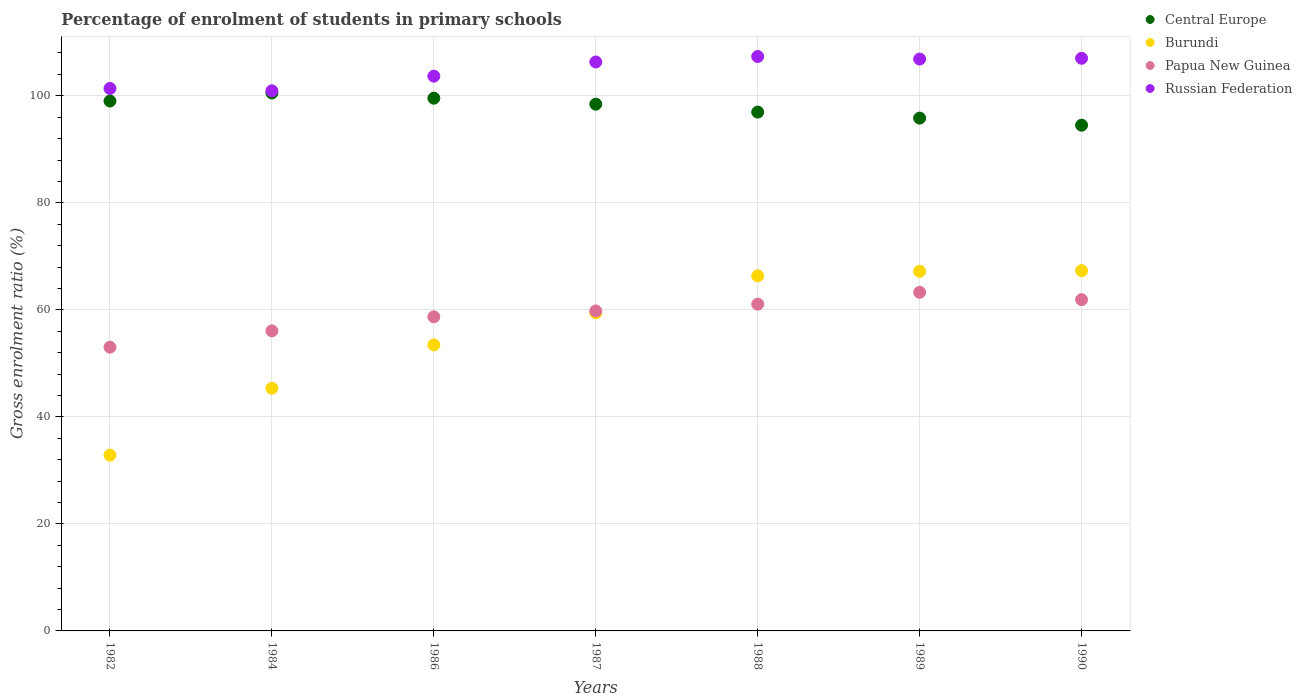How many different coloured dotlines are there?
Ensure brevity in your answer.  4. What is the percentage of students enrolled in primary schools in Central Europe in 1986?
Provide a succinct answer. 99.55. Across all years, what is the maximum percentage of students enrolled in primary schools in Russian Federation?
Give a very brief answer. 107.34. Across all years, what is the minimum percentage of students enrolled in primary schools in Papua New Guinea?
Your answer should be compact. 53.02. In which year was the percentage of students enrolled in primary schools in Russian Federation maximum?
Ensure brevity in your answer.  1988. What is the total percentage of students enrolled in primary schools in Papua New Guinea in the graph?
Provide a succinct answer. 413.85. What is the difference between the percentage of students enrolled in primary schools in Central Europe in 1984 and that in 1989?
Offer a very short reply. 4.69. What is the difference between the percentage of students enrolled in primary schools in Central Europe in 1988 and the percentage of students enrolled in primary schools in Burundi in 1989?
Offer a very short reply. 29.74. What is the average percentage of students enrolled in primary schools in Burundi per year?
Your answer should be very brief. 56. In the year 1988, what is the difference between the percentage of students enrolled in primary schools in Russian Federation and percentage of students enrolled in primary schools in Papua New Guinea?
Give a very brief answer. 46.28. What is the ratio of the percentage of students enrolled in primary schools in Russian Federation in 1988 to that in 1990?
Ensure brevity in your answer.  1. What is the difference between the highest and the second highest percentage of students enrolled in primary schools in Papua New Guinea?
Your response must be concise. 1.37. What is the difference between the highest and the lowest percentage of students enrolled in primary schools in Burundi?
Make the answer very short. 34.46. In how many years, is the percentage of students enrolled in primary schools in Burundi greater than the average percentage of students enrolled in primary schools in Burundi taken over all years?
Offer a very short reply. 4. Is the sum of the percentage of students enrolled in primary schools in Russian Federation in 1989 and 1990 greater than the maximum percentage of students enrolled in primary schools in Central Europe across all years?
Your response must be concise. Yes. Is it the case that in every year, the sum of the percentage of students enrolled in primary schools in Central Europe and percentage of students enrolled in primary schools in Russian Federation  is greater than the sum of percentage of students enrolled in primary schools in Papua New Guinea and percentage of students enrolled in primary schools in Burundi?
Your answer should be compact. Yes. Is the percentage of students enrolled in primary schools in Papua New Guinea strictly greater than the percentage of students enrolled in primary schools in Central Europe over the years?
Make the answer very short. No. How many years are there in the graph?
Provide a succinct answer. 7. What is the difference between two consecutive major ticks on the Y-axis?
Your answer should be compact. 20. Does the graph contain any zero values?
Provide a short and direct response. No. Does the graph contain grids?
Your answer should be very brief. Yes. What is the title of the graph?
Your response must be concise. Percentage of enrolment of students in primary schools. What is the label or title of the Y-axis?
Provide a succinct answer. Gross enrolment ratio (%). What is the Gross enrolment ratio (%) of Central Europe in 1982?
Your answer should be very brief. 99.02. What is the Gross enrolment ratio (%) in Burundi in 1982?
Offer a terse response. 32.86. What is the Gross enrolment ratio (%) of Papua New Guinea in 1982?
Your response must be concise. 53.02. What is the Gross enrolment ratio (%) in Russian Federation in 1982?
Offer a terse response. 101.37. What is the Gross enrolment ratio (%) in Central Europe in 1984?
Keep it short and to the point. 100.52. What is the Gross enrolment ratio (%) of Burundi in 1984?
Provide a short and direct response. 45.35. What is the Gross enrolment ratio (%) of Papua New Guinea in 1984?
Make the answer very short. 56.07. What is the Gross enrolment ratio (%) of Russian Federation in 1984?
Keep it short and to the point. 100.93. What is the Gross enrolment ratio (%) in Central Europe in 1986?
Your answer should be very brief. 99.55. What is the Gross enrolment ratio (%) in Burundi in 1986?
Keep it short and to the point. 53.45. What is the Gross enrolment ratio (%) in Papua New Guinea in 1986?
Give a very brief answer. 58.7. What is the Gross enrolment ratio (%) in Russian Federation in 1986?
Your answer should be very brief. 103.67. What is the Gross enrolment ratio (%) in Central Europe in 1987?
Your response must be concise. 98.44. What is the Gross enrolment ratio (%) in Burundi in 1987?
Your answer should be very brief. 59.44. What is the Gross enrolment ratio (%) in Papua New Guinea in 1987?
Your response must be concise. 59.8. What is the Gross enrolment ratio (%) in Russian Federation in 1987?
Provide a succinct answer. 106.32. What is the Gross enrolment ratio (%) in Central Europe in 1988?
Make the answer very short. 96.96. What is the Gross enrolment ratio (%) of Burundi in 1988?
Your response must be concise. 66.36. What is the Gross enrolment ratio (%) in Papua New Guinea in 1988?
Provide a succinct answer. 61.07. What is the Gross enrolment ratio (%) of Russian Federation in 1988?
Ensure brevity in your answer.  107.34. What is the Gross enrolment ratio (%) of Central Europe in 1989?
Your response must be concise. 95.83. What is the Gross enrolment ratio (%) of Burundi in 1989?
Ensure brevity in your answer.  67.22. What is the Gross enrolment ratio (%) of Papua New Guinea in 1989?
Ensure brevity in your answer.  63.28. What is the Gross enrolment ratio (%) of Russian Federation in 1989?
Make the answer very short. 106.87. What is the Gross enrolment ratio (%) in Central Europe in 1990?
Your response must be concise. 94.51. What is the Gross enrolment ratio (%) of Burundi in 1990?
Provide a succinct answer. 67.32. What is the Gross enrolment ratio (%) of Papua New Guinea in 1990?
Give a very brief answer. 61.91. What is the Gross enrolment ratio (%) in Russian Federation in 1990?
Keep it short and to the point. 107.01. Across all years, what is the maximum Gross enrolment ratio (%) of Central Europe?
Your answer should be very brief. 100.52. Across all years, what is the maximum Gross enrolment ratio (%) of Burundi?
Your answer should be very brief. 67.32. Across all years, what is the maximum Gross enrolment ratio (%) in Papua New Guinea?
Provide a succinct answer. 63.28. Across all years, what is the maximum Gross enrolment ratio (%) in Russian Federation?
Provide a succinct answer. 107.34. Across all years, what is the minimum Gross enrolment ratio (%) in Central Europe?
Offer a very short reply. 94.51. Across all years, what is the minimum Gross enrolment ratio (%) in Burundi?
Provide a succinct answer. 32.86. Across all years, what is the minimum Gross enrolment ratio (%) in Papua New Guinea?
Offer a terse response. 53.02. Across all years, what is the minimum Gross enrolment ratio (%) of Russian Federation?
Your response must be concise. 100.93. What is the total Gross enrolment ratio (%) of Central Europe in the graph?
Give a very brief answer. 684.83. What is the total Gross enrolment ratio (%) in Burundi in the graph?
Ensure brevity in your answer.  391.99. What is the total Gross enrolment ratio (%) in Papua New Guinea in the graph?
Make the answer very short. 413.85. What is the total Gross enrolment ratio (%) in Russian Federation in the graph?
Offer a terse response. 733.53. What is the difference between the Gross enrolment ratio (%) of Central Europe in 1982 and that in 1984?
Offer a very short reply. -1.5. What is the difference between the Gross enrolment ratio (%) in Burundi in 1982 and that in 1984?
Provide a succinct answer. -12.49. What is the difference between the Gross enrolment ratio (%) in Papua New Guinea in 1982 and that in 1984?
Provide a short and direct response. -3.05. What is the difference between the Gross enrolment ratio (%) in Russian Federation in 1982 and that in 1984?
Your answer should be compact. 0.44. What is the difference between the Gross enrolment ratio (%) in Central Europe in 1982 and that in 1986?
Provide a succinct answer. -0.53. What is the difference between the Gross enrolment ratio (%) in Burundi in 1982 and that in 1986?
Your response must be concise. -20.59. What is the difference between the Gross enrolment ratio (%) in Papua New Guinea in 1982 and that in 1986?
Provide a short and direct response. -5.68. What is the difference between the Gross enrolment ratio (%) in Russian Federation in 1982 and that in 1986?
Offer a very short reply. -2.3. What is the difference between the Gross enrolment ratio (%) in Central Europe in 1982 and that in 1987?
Your answer should be compact. 0.59. What is the difference between the Gross enrolment ratio (%) of Burundi in 1982 and that in 1987?
Give a very brief answer. -26.59. What is the difference between the Gross enrolment ratio (%) in Papua New Guinea in 1982 and that in 1987?
Offer a very short reply. -6.78. What is the difference between the Gross enrolment ratio (%) of Russian Federation in 1982 and that in 1987?
Your answer should be compact. -4.95. What is the difference between the Gross enrolment ratio (%) in Central Europe in 1982 and that in 1988?
Make the answer very short. 2.07. What is the difference between the Gross enrolment ratio (%) in Burundi in 1982 and that in 1988?
Your answer should be compact. -33.51. What is the difference between the Gross enrolment ratio (%) of Papua New Guinea in 1982 and that in 1988?
Keep it short and to the point. -8.05. What is the difference between the Gross enrolment ratio (%) of Russian Federation in 1982 and that in 1988?
Your answer should be very brief. -5.97. What is the difference between the Gross enrolment ratio (%) of Central Europe in 1982 and that in 1989?
Give a very brief answer. 3.19. What is the difference between the Gross enrolment ratio (%) in Burundi in 1982 and that in 1989?
Offer a terse response. -34.36. What is the difference between the Gross enrolment ratio (%) in Papua New Guinea in 1982 and that in 1989?
Ensure brevity in your answer.  -10.26. What is the difference between the Gross enrolment ratio (%) of Russian Federation in 1982 and that in 1989?
Your response must be concise. -5.49. What is the difference between the Gross enrolment ratio (%) of Central Europe in 1982 and that in 1990?
Offer a terse response. 4.51. What is the difference between the Gross enrolment ratio (%) in Burundi in 1982 and that in 1990?
Your answer should be compact. -34.46. What is the difference between the Gross enrolment ratio (%) in Papua New Guinea in 1982 and that in 1990?
Provide a succinct answer. -8.89. What is the difference between the Gross enrolment ratio (%) of Russian Federation in 1982 and that in 1990?
Make the answer very short. -5.64. What is the difference between the Gross enrolment ratio (%) of Central Europe in 1984 and that in 1986?
Offer a terse response. 0.97. What is the difference between the Gross enrolment ratio (%) of Burundi in 1984 and that in 1986?
Your answer should be very brief. -8.1. What is the difference between the Gross enrolment ratio (%) of Papua New Guinea in 1984 and that in 1986?
Make the answer very short. -2.63. What is the difference between the Gross enrolment ratio (%) of Russian Federation in 1984 and that in 1986?
Offer a very short reply. -2.74. What is the difference between the Gross enrolment ratio (%) of Central Europe in 1984 and that in 1987?
Give a very brief answer. 2.09. What is the difference between the Gross enrolment ratio (%) in Burundi in 1984 and that in 1987?
Your response must be concise. -14.09. What is the difference between the Gross enrolment ratio (%) in Papua New Guinea in 1984 and that in 1987?
Provide a succinct answer. -3.73. What is the difference between the Gross enrolment ratio (%) in Russian Federation in 1984 and that in 1987?
Your response must be concise. -5.39. What is the difference between the Gross enrolment ratio (%) in Central Europe in 1984 and that in 1988?
Your response must be concise. 3.56. What is the difference between the Gross enrolment ratio (%) of Burundi in 1984 and that in 1988?
Make the answer very short. -21.01. What is the difference between the Gross enrolment ratio (%) in Papua New Guinea in 1984 and that in 1988?
Keep it short and to the point. -5. What is the difference between the Gross enrolment ratio (%) in Russian Federation in 1984 and that in 1988?
Provide a short and direct response. -6.41. What is the difference between the Gross enrolment ratio (%) of Central Europe in 1984 and that in 1989?
Keep it short and to the point. 4.69. What is the difference between the Gross enrolment ratio (%) of Burundi in 1984 and that in 1989?
Your response must be concise. -21.87. What is the difference between the Gross enrolment ratio (%) of Papua New Guinea in 1984 and that in 1989?
Provide a succinct answer. -7.2. What is the difference between the Gross enrolment ratio (%) of Russian Federation in 1984 and that in 1989?
Offer a very short reply. -5.93. What is the difference between the Gross enrolment ratio (%) in Central Europe in 1984 and that in 1990?
Keep it short and to the point. 6.01. What is the difference between the Gross enrolment ratio (%) in Burundi in 1984 and that in 1990?
Offer a terse response. -21.97. What is the difference between the Gross enrolment ratio (%) in Papua New Guinea in 1984 and that in 1990?
Provide a short and direct response. -5.83. What is the difference between the Gross enrolment ratio (%) of Russian Federation in 1984 and that in 1990?
Make the answer very short. -6.08. What is the difference between the Gross enrolment ratio (%) in Central Europe in 1986 and that in 1987?
Provide a short and direct response. 1.12. What is the difference between the Gross enrolment ratio (%) in Burundi in 1986 and that in 1987?
Provide a succinct answer. -5.99. What is the difference between the Gross enrolment ratio (%) in Papua New Guinea in 1986 and that in 1987?
Make the answer very short. -1.11. What is the difference between the Gross enrolment ratio (%) in Russian Federation in 1986 and that in 1987?
Ensure brevity in your answer.  -2.65. What is the difference between the Gross enrolment ratio (%) of Central Europe in 1986 and that in 1988?
Your answer should be very brief. 2.6. What is the difference between the Gross enrolment ratio (%) of Burundi in 1986 and that in 1988?
Offer a very short reply. -12.92. What is the difference between the Gross enrolment ratio (%) of Papua New Guinea in 1986 and that in 1988?
Your answer should be compact. -2.37. What is the difference between the Gross enrolment ratio (%) in Russian Federation in 1986 and that in 1988?
Give a very brief answer. -3.67. What is the difference between the Gross enrolment ratio (%) in Central Europe in 1986 and that in 1989?
Your answer should be compact. 3.72. What is the difference between the Gross enrolment ratio (%) in Burundi in 1986 and that in 1989?
Your answer should be very brief. -13.77. What is the difference between the Gross enrolment ratio (%) of Papua New Guinea in 1986 and that in 1989?
Provide a short and direct response. -4.58. What is the difference between the Gross enrolment ratio (%) in Russian Federation in 1986 and that in 1989?
Provide a short and direct response. -3.2. What is the difference between the Gross enrolment ratio (%) in Central Europe in 1986 and that in 1990?
Your response must be concise. 5.04. What is the difference between the Gross enrolment ratio (%) in Burundi in 1986 and that in 1990?
Offer a very short reply. -13.87. What is the difference between the Gross enrolment ratio (%) in Papua New Guinea in 1986 and that in 1990?
Give a very brief answer. -3.21. What is the difference between the Gross enrolment ratio (%) in Russian Federation in 1986 and that in 1990?
Ensure brevity in your answer.  -3.34. What is the difference between the Gross enrolment ratio (%) of Central Europe in 1987 and that in 1988?
Your answer should be very brief. 1.48. What is the difference between the Gross enrolment ratio (%) in Burundi in 1987 and that in 1988?
Provide a succinct answer. -6.92. What is the difference between the Gross enrolment ratio (%) in Papua New Guinea in 1987 and that in 1988?
Offer a terse response. -1.27. What is the difference between the Gross enrolment ratio (%) in Russian Federation in 1987 and that in 1988?
Offer a terse response. -1.02. What is the difference between the Gross enrolment ratio (%) in Central Europe in 1987 and that in 1989?
Ensure brevity in your answer.  2.6. What is the difference between the Gross enrolment ratio (%) of Burundi in 1987 and that in 1989?
Offer a terse response. -7.78. What is the difference between the Gross enrolment ratio (%) in Papua New Guinea in 1987 and that in 1989?
Offer a terse response. -3.47. What is the difference between the Gross enrolment ratio (%) of Russian Federation in 1987 and that in 1989?
Keep it short and to the point. -0.54. What is the difference between the Gross enrolment ratio (%) of Central Europe in 1987 and that in 1990?
Offer a very short reply. 3.93. What is the difference between the Gross enrolment ratio (%) of Burundi in 1987 and that in 1990?
Give a very brief answer. -7.88. What is the difference between the Gross enrolment ratio (%) of Papua New Guinea in 1987 and that in 1990?
Offer a very short reply. -2.1. What is the difference between the Gross enrolment ratio (%) of Russian Federation in 1987 and that in 1990?
Your answer should be very brief. -0.69. What is the difference between the Gross enrolment ratio (%) of Central Europe in 1988 and that in 1989?
Give a very brief answer. 1.12. What is the difference between the Gross enrolment ratio (%) in Burundi in 1988 and that in 1989?
Your answer should be compact. -0.85. What is the difference between the Gross enrolment ratio (%) in Papua New Guinea in 1988 and that in 1989?
Ensure brevity in your answer.  -2.21. What is the difference between the Gross enrolment ratio (%) in Russian Federation in 1988 and that in 1989?
Provide a short and direct response. 0.48. What is the difference between the Gross enrolment ratio (%) of Central Europe in 1988 and that in 1990?
Give a very brief answer. 2.45. What is the difference between the Gross enrolment ratio (%) of Burundi in 1988 and that in 1990?
Your answer should be very brief. -0.96. What is the difference between the Gross enrolment ratio (%) of Papua New Guinea in 1988 and that in 1990?
Make the answer very short. -0.84. What is the difference between the Gross enrolment ratio (%) of Russian Federation in 1988 and that in 1990?
Offer a very short reply. 0.33. What is the difference between the Gross enrolment ratio (%) of Central Europe in 1989 and that in 1990?
Make the answer very short. 1.32. What is the difference between the Gross enrolment ratio (%) of Burundi in 1989 and that in 1990?
Provide a succinct answer. -0.1. What is the difference between the Gross enrolment ratio (%) in Papua New Guinea in 1989 and that in 1990?
Offer a very short reply. 1.37. What is the difference between the Gross enrolment ratio (%) in Russian Federation in 1989 and that in 1990?
Provide a short and direct response. -0.15. What is the difference between the Gross enrolment ratio (%) of Central Europe in 1982 and the Gross enrolment ratio (%) of Burundi in 1984?
Give a very brief answer. 53.67. What is the difference between the Gross enrolment ratio (%) of Central Europe in 1982 and the Gross enrolment ratio (%) of Papua New Guinea in 1984?
Offer a terse response. 42.95. What is the difference between the Gross enrolment ratio (%) in Central Europe in 1982 and the Gross enrolment ratio (%) in Russian Federation in 1984?
Make the answer very short. -1.91. What is the difference between the Gross enrolment ratio (%) of Burundi in 1982 and the Gross enrolment ratio (%) of Papua New Guinea in 1984?
Your response must be concise. -23.22. What is the difference between the Gross enrolment ratio (%) of Burundi in 1982 and the Gross enrolment ratio (%) of Russian Federation in 1984?
Provide a short and direct response. -68.08. What is the difference between the Gross enrolment ratio (%) in Papua New Guinea in 1982 and the Gross enrolment ratio (%) in Russian Federation in 1984?
Ensure brevity in your answer.  -47.91. What is the difference between the Gross enrolment ratio (%) in Central Europe in 1982 and the Gross enrolment ratio (%) in Burundi in 1986?
Offer a terse response. 45.58. What is the difference between the Gross enrolment ratio (%) in Central Europe in 1982 and the Gross enrolment ratio (%) in Papua New Guinea in 1986?
Your response must be concise. 40.33. What is the difference between the Gross enrolment ratio (%) of Central Europe in 1982 and the Gross enrolment ratio (%) of Russian Federation in 1986?
Provide a short and direct response. -4.65. What is the difference between the Gross enrolment ratio (%) of Burundi in 1982 and the Gross enrolment ratio (%) of Papua New Guinea in 1986?
Provide a short and direct response. -25.84. What is the difference between the Gross enrolment ratio (%) of Burundi in 1982 and the Gross enrolment ratio (%) of Russian Federation in 1986?
Your answer should be compact. -70.81. What is the difference between the Gross enrolment ratio (%) in Papua New Guinea in 1982 and the Gross enrolment ratio (%) in Russian Federation in 1986?
Ensure brevity in your answer.  -50.65. What is the difference between the Gross enrolment ratio (%) in Central Europe in 1982 and the Gross enrolment ratio (%) in Burundi in 1987?
Your response must be concise. 39.58. What is the difference between the Gross enrolment ratio (%) of Central Europe in 1982 and the Gross enrolment ratio (%) of Papua New Guinea in 1987?
Your response must be concise. 39.22. What is the difference between the Gross enrolment ratio (%) in Central Europe in 1982 and the Gross enrolment ratio (%) in Russian Federation in 1987?
Offer a very short reply. -7.3. What is the difference between the Gross enrolment ratio (%) in Burundi in 1982 and the Gross enrolment ratio (%) in Papua New Guinea in 1987?
Offer a terse response. -26.95. What is the difference between the Gross enrolment ratio (%) of Burundi in 1982 and the Gross enrolment ratio (%) of Russian Federation in 1987?
Your response must be concise. -73.47. What is the difference between the Gross enrolment ratio (%) of Papua New Guinea in 1982 and the Gross enrolment ratio (%) of Russian Federation in 1987?
Provide a succinct answer. -53.3. What is the difference between the Gross enrolment ratio (%) in Central Europe in 1982 and the Gross enrolment ratio (%) in Burundi in 1988?
Your answer should be very brief. 32.66. What is the difference between the Gross enrolment ratio (%) in Central Europe in 1982 and the Gross enrolment ratio (%) in Papua New Guinea in 1988?
Give a very brief answer. 37.95. What is the difference between the Gross enrolment ratio (%) of Central Europe in 1982 and the Gross enrolment ratio (%) of Russian Federation in 1988?
Make the answer very short. -8.32. What is the difference between the Gross enrolment ratio (%) in Burundi in 1982 and the Gross enrolment ratio (%) in Papua New Guinea in 1988?
Your answer should be very brief. -28.21. What is the difference between the Gross enrolment ratio (%) of Burundi in 1982 and the Gross enrolment ratio (%) of Russian Federation in 1988?
Ensure brevity in your answer.  -74.49. What is the difference between the Gross enrolment ratio (%) of Papua New Guinea in 1982 and the Gross enrolment ratio (%) of Russian Federation in 1988?
Offer a terse response. -54.32. What is the difference between the Gross enrolment ratio (%) in Central Europe in 1982 and the Gross enrolment ratio (%) in Burundi in 1989?
Provide a succinct answer. 31.81. What is the difference between the Gross enrolment ratio (%) of Central Europe in 1982 and the Gross enrolment ratio (%) of Papua New Guinea in 1989?
Keep it short and to the point. 35.75. What is the difference between the Gross enrolment ratio (%) in Central Europe in 1982 and the Gross enrolment ratio (%) in Russian Federation in 1989?
Keep it short and to the point. -7.84. What is the difference between the Gross enrolment ratio (%) in Burundi in 1982 and the Gross enrolment ratio (%) in Papua New Guinea in 1989?
Offer a terse response. -30.42. What is the difference between the Gross enrolment ratio (%) of Burundi in 1982 and the Gross enrolment ratio (%) of Russian Federation in 1989?
Provide a succinct answer. -74.01. What is the difference between the Gross enrolment ratio (%) of Papua New Guinea in 1982 and the Gross enrolment ratio (%) of Russian Federation in 1989?
Make the answer very short. -53.84. What is the difference between the Gross enrolment ratio (%) in Central Europe in 1982 and the Gross enrolment ratio (%) in Burundi in 1990?
Offer a terse response. 31.7. What is the difference between the Gross enrolment ratio (%) in Central Europe in 1982 and the Gross enrolment ratio (%) in Papua New Guinea in 1990?
Offer a terse response. 37.12. What is the difference between the Gross enrolment ratio (%) of Central Europe in 1982 and the Gross enrolment ratio (%) of Russian Federation in 1990?
Make the answer very short. -7.99. What is the difference between the Gross enrolment ratio (%) of Burundi in 1982 and the Gross enrolment ratio (%) of Papua New Guinea in 1990?
Offer a very short reply. -29.05. What is the difference between the Gross enrolment ratio (%) of Burundi in 1982 and the Gross enrolment ratio (%) of Russian Federation in 1990?
Give a very brief answer. -74.16. What is the difference between the Gross enrolment ratio (%) in Papua New Guinea in 1982 and the Gross enrolment ratio (%) in Russian Federation in 1990?
Provide a succinct answer. -53.99. What is the difference between the Gross enrolment ratio (%) in Central Europe in 1984 and the Gross enrolment ratio (%) in Burundi in 1986?
Make the answer very short. 47.08. What is the difference between the Gross enrolment ratio (%) in Central Europe in 1984 and the Gross enrolment ratio (%) in Papua New Guinea in 1986?
Make the answer very short. 41.82. What is the difference between the Gross enrolment ratio (%) in Central Europe in 1984 and the Gross enrolment ratio (%) in Russian Federation in 1986?
Provide a succinct answer. -3.15. What is the difference between the Gross enrolment ratio (%) of Burundi in 1984 and the Gross enrolment ratio (%) of Papua New Guinea in 1986?
Your answer should be compact. -13.35. What is the difference between the Gross enrolment ratio (%) in Burundi in 1984 and the Gross enrolment ratio (%) in Russian Federation in 1986?
Offer a very short reply. -58.32. What is the difference between the Gross enrolment ratio (%) in Papua New Guinea in 1984 and the Gross enrolment ratio (%) in Russian Federation in 1986?
Your answer should be very brief. -47.6. What is the difference between the Gross enrolment ratio (%) of Central Europe in 1984 and the Gross enrolment ratio (%) of Burundi in 1987?
Make the answer very short. 41.08. What is the difference between the Gross enrolment ratio (%) in Central Europe in 1984 and the Gross enrolment ratio (%) in Papua New Guinea in 1987?
Provide a succinct answer. 40.72. What is the difference between the Gross enrolment ratio (%) in Central Europe in 1984 and the Gross enrolment ratio (%) in Russian Federation in 1987?
Your answer should be compact. -5.8. What is the difference between the Gross enrolment ratio (%) in Burundi in 1984 and the Gross enrolment ratio (%) in Papua New Guinea in 1987?
Offer a terse response. -14.45. What is the difference between the Gross enrolment ratio (%) of Burundi in 1984 and the Gross enrolment ratio (%) of Russian Federation in 1987?
Your answer should be very brief. -60.98. What is the difference between the Gross enrolment ratio (%) in Papua New Guinea in 1984 and the Gross enrolment ratio (%) in Russian Federation in 1987?
Give a very brief answer. -50.25. What is the difference between the Gross enrolment ratio (%) of Central Europe in 1984 and the Gross enrolment ratio (%) of Burundi in 1988?
Ensure brevity in your answer.  34.16. What is the difference between the Gross enrolment ratio (%) in Central Europe in 1984 and the Gross enrolment ratio (%) in Papua New Guinea in 1988?
Your answer should be compact. 39.45. What is the difference between the Gross enrolment ratio (%) of Central Europe in 1984 and the Gross enrolment ratio (%) of Russian Federation in 1988?
Offer a terse response. -6.82. What is the difference between the Gross enrolment ratio (%) of Burundi in 1984 and the Gross enrolment ratio (%) of Papua New Guinea in 1988?
Your answer should be compact. -15.72. What is the difference between the Gross enrolment ratio (%) of Burundi in 1984 and the Gross enrolment ratio (%) of Russian Federation in 1988?
Make the answer very short. -62. What is the difference between the Gross enrolment ratio (%) in Papua New Guinea in 1984 and the Gross enrolment ratio (%) in Russian Federation in 1988?
Offer a terse response. -51.27. What is the difference between the Gross enrolment ratio (%) in Central Europe in 1984 and the Gross enrolment ratio (%) in Burundi in 1989?
Give a very brief answer. 33.31. What is the difference between the Gross enrolment ratio (%) of Central Europe in 1984 and the Gross enrolment ratio (%) of Papua New Guinea in 1989?
Ensure brevity in your answer.  37.24. What is the difference between the Gross enrolment ratio (%) of Central Europe in 1984 and the Gross enrolment ratio (%) of Russian Federation in 1989?
Make the answer very short. -6.34. What is the difference between the Gross enrolment ratio (%) in Burundi in 1984 and the Gross enrolment ratio (%) in Papua New Guinea in 1989?
Provide a succinct answer. -17.93. What is the difference between the Gross enrolment ratio (%) of Burundi in 1984 and the Gross enrolment ratio (%) of Russian Federation in 1989?
Provide a succinct answer. -61.52. What is the difference between the Gross enrolment ratio (%) of Papua New Guinea in 1984 and the Gross enrolment ratio (%) of Russian Federation in 1989?
Offer a very short reply. -50.79. What is the difference between the Gross enrolment ratio (%) of Central Europe in 1984 and the Gross enrolment ratio (%) of Burundi in 1990?
Your response must be concise. 33.2. What is the difference between the Gross enrolment ratio (%) of Central Europe in 1984 and the Gross enrolment ratio (%) of Papua New Guinea in 1990?
Offer a terse response. 38.62. What is the difference between the Gross enrolment ratio (%) of Central Europe in 1984 and the Gross enrolment ratio (%) of Russian Federation in 1990?
Keep it short and to the point. -6.49. What is the difference between the Gross enrolment ratio (%) in Burundi in 1984 and the Gross enrolment ratio (%) in Papua New Guinea in 1990?
Your response must be concise. -16.56. What is the difference between the Gross enrolment ratio (%) of Burundi in 1984 and the Gross enrolment ratio (%) of Russian Federation in 1990?
Keep it short and to the point. -61.66. What is the difference between the Gross enrolment ratio (%) in Papua New Guinea in 1984 and the Gross enrolment ratio (%) in Russian Federation in 1990?
Your response must be concise. -50.94. What is the difference between the Gross enrolment ratio (%) of Central Europe in 1986 and the Gross enrolment ratio (%) of Burundi in 1987?
Your answer should be compact. 40.11. What is the difference between the Gross enrolment ratio (%) in Central Europe in 1986 and the Gross enrolment ratio (%) in Papua New Guinea in 1987?
Offer a very short reply. 39.75. What is the difference between the Gross enrolment ratio (%) in Central Europe in 1986 and the Gross enrolment ratio (%) in Russian Federation in 1987?
Your answer should be compact. -6.77. What is the difference between the Gross enrolment ratio (%) of Burundi in 1986 and the Gross enrolment ratio (%) of Papua New Guinea in 1987?
Offer a very short reply. -6.36. What is the difference between the Gross enrolment ratio (%) of Burundi in 1986 and the Gross enrolment ratio (%) of Russian Federation in 1987?
Ensure brevity in your answer.  -52.88. What is the difference between the Gross enrolment ratio (%) in Papua New Guinea in 1986 and the Gross enrolment ratio (%) in Russian Federation in 1987?
Ensure brevity in your answer.  -47.63. What is the difference between the Gross enrolment ratio (%) of Central Europe in 1986 and the Gross enrolment ratio (%) of Burundi in 1988?
Offer a terse response. 33.19. What is the difference between the Gross enrolment ratio (%) in Central Europe in 1986 and the Gross enrolment ratio (%) in Papua New Guinea in 1988?
Your answer should be very brief. 38.48. What is the difference between the Gross enrolment ratio (%) in Central Europe in 1986 and the Gross enrolment ratio (%) in Russian Federation in 1988?
Provide a short and direct response. -7.79. What is the difference between the Gross enrolment ratio (%) in Burundi in 1986 and the Gross enrolment ratio (%) in Papua New Guinea in 1988?
Provide a succinct answer. -7.62. What is the difference between the Gross enrolment ratio (%) of Burundi in 1986 and the Gross enrolment ratio (%) of Russian Federation in 1988?
Give a very brief answer. -53.9. What is the difference between the Gross enrolment ratio (%) in Papua New Guinea in 1986 and the Gross enrolment ratio (%) in Russian Federation in 1988?
Offer a terse response. -48.65. What is the difference between the Gross enrolment ratio (%) of Central Europe in 1986 and the Gross enrolment ratio (%) of Burundi in 1989?
Make the answer very short. 32.34. What is the difference between the Gross enrolment ratio (%) of Central Europe in 1986 and the Gross enrolment ratio (%) of Papua New Guinea in 1989?
Provide a succinct answer. 36.28. What is the difference between the Gross enrolment ratio (%) in Central Europe in 1986 and the Gross enrolment ratio (%) in Russian Federation in 1989?
Offer a terse response. -7.31. What is the difference between the Gross enrolment ratio (%) of Burundi in 1986 and the Gross enrolment ratio (%) of Papua New Guinea in 1989?
Your answer should be very brief. -9.83. What is the difference between the Gross enrolment ratio (%) of Burundi in 1986 and the Gross enrolment ratio (%) of Russian Federation in 1989?
Offer a very short reply. -53.42. What is the difference between the Gross enrolment ratio (%) in Papua New Guinea in 1986 and the Gross enrolment ratio (%) in Russian Federation in 1989?
Your answer should be very brief. -48.17. What is the difference between the Gross enrolment ratio (%) in Central Europe in 1986 and the Gross enrolment ratio (%) in Burundi in 1990?
Give a very brief answer. 32.23. What is the difference between the Gross enrolment ratio (%) of Central Europe in 1986 and the Gross enrolment ratio (%) of Papua New Guinea in 1990?
Offer a very short reply. 37.65. What is the difference between the Gross enrolment ratio (%) in Central Europe in 1986 and the Gross enrolment ratio (%) in Russian Federation in 1990?
Offer a terse response. -7.46. What is the difference between the Gross enrolment ratio (%) of Burundi in 1986 and the Gross enrolment ratio (%) of Papua New Guinea in 1990?
Your response must be concise. -8.46. What is the difference between the Gross enrolment ratio (%) in Burundi in 1986 and the Gross enrolment ratio (%) in Russian Federation in 1990?
Offer a very short reply. -53.57. What is the difference between the Gross enrolment ratio (%) in Papua New Guinea in 1986 and the Gross enrolment ratio (%) in Russian Federation in 1990?
Your answer should be very brief. -48.32. What is the difference between the Gross enrolment ratio (%) in Central Europe in 1987 and the Gross enrolment ratio (%) in Burundi in 1988?
Provide a succinct answer. 32.07. What is the difference between the Gross enrolment ratio (%) of Central Europe in 1987 and the Gross enrolment ratio (%) of Papua New Guinea in 1988?
Offer a very short reply. 37.37. What is the difference between the Gross enrolment ratio (%) of Central Europe in 1987 and the Gross enrolment ratio (%) of Russian Federation in 1988?
Provide a short and direct response. -8.91. What is the difference between the Gross enrolment ratio (%) of Burundi in 1987 and the Gross enrolment ratio (%) of Papua New Guinea in 1988?
Give a very brief answer. -1.63. What is the difference between the Gross enrolment ratio (%) of Burundi in 1987 and the Gross enrolment ratio (%) of Russian Federation in 1988?
Offer a terse response. -47.9. What is the difference between the Gross enrolment ratio (%) of Papua New Guinea in 1987 and the Gross enrolment ratio (%) of Russian Federation in 1988?
Ensure brevity in your answer.  -47.54. What is the difference between the Gross enrolment ratio (%) in Central Europe in 1987 and the Gross enrolment ratio (%) in Burundi in 1989?
Keep it short and to the point. 31.22. What is the difference between the Gross enrolment ratio (%) of Central Europe in 1987 and the Gross enrolment ratio (%) of Papua New Guinea in 1989?
Your answer should be very brief. 35.16. What is the difference between the Gross enrolment ratio (%) of Central Europe in 1987 and the Gross enrolment ratio (%) of Russian Federation in 1989?
Your answer should be very brief. -8.43. What is the difference between the Gross enrolment ratio (%) in Burundi in 1987 and the Gross enrolment ratio (%) in Papua New Guinea in 1989?
Provide a short and direct response. -3.84. What is the difference between the Gross enrolment ratio (%) of Burundi in 1987 and the Gross enrolment ratio (%) of Russian Federation in 1989?
Provide a short and direct response. -47.42. What is the difference between the Gross enrolment ratio (%) in Papua New Guinea in 1987 and the Gross enrolment ratio (%) in Russian Federation in 1989?
Your response must be concise. -47.06. What is the difference between the Gross enrolment ratio (%) in Central Europe in 1987 and the Gross enrolment ratio (%) in Burundi in 1990?
Offer a very short reply. 31.12. What is the difference between the Gross enrolment ratio (%) of Central Europe in 1987 and the Gross enrolment ratio (%) of Papua New Guinea in 1990?
Keep it short and to the point. 36.53. What is the difference between the Gross enrolment ratio (%) in Central Europe in 1987 and the Gross enrolment ratio (%) in Russian Federation in 1990?
Give a very brief answer. -8.58. What is the difference between the Gross enrolment ratio (%) of Burundi in 1987 and the Gross enrolment ratio (%) of Papua New Guinea in 1990?
Give a very brief answer. -2.47. What is the difference between the Gross enrolment ratio (%) of Burundi in 1987 and the Gross enrolment ratio (%) of Russian Federation in 1990?
Offer a terse response. -47.57. What is the difference between the Gross enrolment ratio (%) in Papua New Guinea in 1987 and the Gross enrolment ratio (%) in Russian Federation in 1990?
Provide a short and direct response. -47.21. What is the difference between the Gross enrolment ratio (%) of Central Europe in 1988 and the Gross enrolment ratio (%) of Burundi in 1989?
Offer a terse response. 29.74. What is the difference between the Gross enrolment ratio (%) in Central Europe in 1988 and the Gross enrolment ratio (%) in Papua New Guinea in 1989?
Give a very brief answer. 33.68. What is the difference between the Gross enrolment ratio (%) of Central Europe in 1988 and the Gross enrolment ratio (%) of Russian Federation in 1989?
Provide a succinct answer. -9.91. What is the difference between the Gross enrolment ratio (%) of Burundi in 1988 and the Gross enrolment ratio (%) of Papua New Guinea in 1989?
Your answer should be very brief. 3.09. What is the difference between the Gross enrolment ratio (%) in Burundi in 1988 and the Gross enrolment ratio (%) in Russian Federation in 1989?
Your answer should be very brief. -40.5. What is the difference between the Gross enrolment ratio (%) of Papua New Guinea in 1988 and the Gross enrolment ratio (%) of Russian Federation in 1989?
Provide a succinct answer. -45.8. What is the difference between the Gross enrolment ratio (%) of Central Europe in 1988 and the Gross enrolment ratio (%) of Burundi in 1990?
Your answer should be very brief. 29.64. What is the difference between the Gross enrolment ratio (%) in Central Europe in 1988 and the Gross enrolment ratio (%) in Papua New Guinea in 1990?
Provide a succinct answer. 35.05. What is the difference between the Gross enrolment ratio (%) in Central Europe in 1988 and the Gross enrolment ratio (%) in Russian Federation in 1990?
Give a very brief answer. -10.06. What is the difference between the Gross enrolment ratio (%) of Burundi in 1988 and the Gross enrolment ratio (%) of Papua New Guinea in 1990?
Provide a short and direct response. 4.46. What is the difference between the Gross enrolment ratio (%) in Burundi in 1988 and the Gross enrolment ratio (%) in Russian Federation in 1990?
Provide a short and direct response. -40.65. What is the difference between the Gross enrolment ratio (%) in Papua New Guinea in 1988 and the Gross enrolment ratio (%) in Russian Federation in 1990?
Provide a succinct answer. -45.94. What is the difference between the Gross enrolment ratio (%) in Central Europe in 1989 and the Gross enrolment ratio (%) in Burundi in 1990?
Offer a terse response. 28.51. What is the difference between the Gross enrolment ratio (%) of Central Europe in 1989 and the Gross enrolment ratio (%) of Papua New Guinea in 1990?
Make the answer very short. 33.93. What is the difference between the Gross enrolment ratio (%) of Central Europe in 1989 and the Gross enrolment ratio (%) of Russian Federation in 1990?
Offer a very short reply. -11.18. What is the difference between the Gross enrolment ratio (%) of Burundi in 1989 and the Gross enrolment ratio (%) of Papua New Guinea in 1990?
Keep it short and to the point. 5.31. What is the difference between the Gross enrolment ratio (%) of Burundi in 1989 and the Gross enrolment ratio (%) of Russian Federation in 1990?
Provide a short and direct response. -39.8. What is the difference between the Gross enrolment ratio (%) in Papua New Guinea in 1989 and the Gross enrolment ratio (%) in Russian Federation in 1990?
Your response must be concise. -43.74. What is the average Gross enrolment ratio (%) in Central Europe per year?
Keep it short and to the point. 97.83. What is the average Gross enrolment ratio (%) in Burundi per year?
Your answer should be compact. 56. What is the average Gross enrolment ratio (%) in Papua New Guinea per year?
Your answer should be compact. 59.12. What is the average Gross enrolment ratio (%) in Russian Federation per year?
Keep it short and to the point. 104.79. In the year 1982, what is the difference between the Gross enrolment ratio (%) of Central Europe and Gross enrolment ratio (%) of Burundi?
Ensure brevity in your answer.  66.17. In the year 1982, what is the difference between the Gross enrolment ratio (%) in Central Europe and Gross enrolment ratio (%) in Papua New Guinea?
Offer a very short reply. 46. In the year 1982, what is the difference between the Gross enrolment ratio (%) in Central Europe and Gross enrolment ratio (%) in Russian Federation?
Provide a short and direct response. -2.35. In the year 1982, what is the difference between the Gross enrolment ratio (%) in Burundi and Gross enrolment ratio (%) in Papua New Guinea?
Your response must be concise. -20.16. In the year 1982, what is the difference between the Gross enrolment ratio (%) in Burundi and Gross enrolment ratio (%) in Russian Federation?
Make the answer very short. -68.52. In the year 1982, what is the difference between the Gross enrolment ratio (%) of Papua New Guinea and Gross enrolment ratio (%) of Russian Federation?
Provide a short and direct response. -48.35. In the year 1984, what is the difference between the Gross enrolment ratio (%) of Central Europe and Gross enrolment ratio (%) of Burundi?
Make the answer very short. 55.17. In the year 1984, what is the difference between the Gross enrolment ratio (%) of Central Europe and Gross enrolment ratio (%) of Papua New Guinea?
Your answer should be compact. 44.45. In the year 1984, what is the difference between the Gross enrolment ratio (%) in Central Europe and Gross enrolment ratio (%) in Russian Federation?
Make the answer very short. -0.41. In the year 1984, what is the difference between the Gross enrolment ratio (%) in Burundi and Gross enrolment ratio (%) in Papua New Guinea?
Your answer should be compact. -10.72. In the year 1984, what is the difference between the Gross enrolment ratio (%) in Burundi and Gross enrolment ratio (%) in Russian Federation?
Your answer should be very brief. -55.59. In the year 1984, what is the difference between the Gross enrolment ratio (%) in Papua New Guinea and Gross enrolment ratio (%) in Russian Federation?
Make the answer very short. -44.86. In the year 1986, what is the difference between the Gross enrolment ratio (%) in Central Europe and Gross enrolment ratio (%) in Burundi?
Make the answer very short. 46.11. In the year 1986, what is the difference between the Gross enrolment ratio (%) in Central Europe and Gross enrolment ratio (%) in Papua New Guinea?
Your answer should be compact. 40.86. In the year 1986, what is the difference between the Gross enrolment ratio (%) in Central Europe and Gross enrolment ratio (%) in Russian Federation?
Provide a short and direct response. -4.12. In the year 1986, what is the difference between the Gross enrolment ratio (%) of Burundi and Gross enrolment ratio (%) of Papua New Guinea?
Keep it short and to the point. -5.25. In the year 1986, what is the difference between the Gross enrolment ratio (%) of Burundi and Gross enrolment ratio (%) of Russian Federation?
Offer a terse response. -50.22. In the year 1986, what is the difference between the Gross enrolment ratio (%) of Papua New Guinea and Gross enrolment ratio (%) of Russian Federation?
Ensure brevity in your answer.  -44.97. In the year 1987, what is the difference between the Gross enrolment ratio (%) of Central Europe and Gross enrolment ratio (%) of Burundi?
Offer a very short reply. 38.99. In the year 1987, what is the difference between the Gross enrolment ratio (%) of Central Europe and Gross enrolment ratio (%) of Papua New Guinea?
Your response must be concise. 38.63. In the year 1987, what is the difference between the Gross enrolment ratio (%) of Central Europe and Gross enrolment ratio (%) of Russian Federation?
Give a very brief answer. -7.89. In the year 1987, what is the difference between the Gross enrolment ratio (%) of Burundi and Gross enrolment ratio (%) of Papua New Guinea?
Give a very brief answer. -0.36. In the year 1987, what is the difference between the Gross enrolment ratio (%) of Burundi and Gross enrolment ratio (%) of Russian Federation?
Offer a terse response. -46.88. In the year 1987, what is the difference between the Gross enrolment ratio (%) in Papua New Guinea and Gross enrolment ratio (%) in Russian Federation?
Offer a terse response. -46.52. In the year 1988, what is the difference between the Gross enrolment ratio (%) of Central Europe and Gross enrolment ratio (%) of Burundi?
Your response must be concise. 30.59. In the year 1988, what is the difference between the Gross enrolment ratio (%) of Central Europe and Gross enrolment ratio (%) of Papua New Guinea?
Your answer should be very brief. 35.89. In the year 1988, what is the difference between the Gross enrolment ratio (%) in Central Europe and Gross enrolment ratio (%) in Russian Federation?
Offer a very short reply. -10.39. In the year 1988, what is the difference between the Gross enrolment ratio (%) of Burundi and Gross enrolment ratio (%) of Papua New Guinea?
Provide a succinct answer. 5.29. In the year 1988, what is the difference between the Gross enrolment ratio (%) in Burundi and Gross enrolment ratio (%) in Russian Federation?
Your answer should be compact. -40.98. In the year 1988, what is the difference between the Gross enrolment ratio (%) in Papua New Guinea and Gross enrolment ratio (%) in Russian Federation?
Make the answer very short. -46.28. In the year 1989, what is the difference between the Gross enrolment ratio (%) of Central Europe and Gross enrolment ratio (%) of Burundi?
Provide a short and direct response. 28.62. In the year 1989, what is the difference between the Gross enrolment ratio (%) of Central Europe and Gross enrolment ratio (%) of Papua New Guinea?
Your response must be concise. 32.56. In the year 1989, what is the difference between the Gross enrolment ratio (%) in Central Europe and Gross enrolment ratio (%) in Russian Federation?
Your response must be concise. -11.03. In the year 1989, what is the difference between the Gross enrolment ratio (%) in Burundi and Gross enrolment ratio (%) in Papua New Guinea?
Your answer should be very brief. 3.94. In the year 1989, what is the difference between the Gross enrolment ratio (%) in Burundi and Gross enrolment ratio (%) in Russian Federation?
Provide a short and direct response. -39.65. In the year 1989, what is the difference between the Gross enrolment ratio (%) in Papua New Guinea and Gross enrolment ratio (%) in Russian Federation?
Ensure brevity in your answer.  -43.59. In the year 1990, what is the difference between the Gross enrolment ratio (%) in Central Europe and Gross enrolment ratio (%) in Burundi?
Give a very brief answer. 27.19. In the year 1990, what is the difference between the Gross enrolment ratio (%) in Central Europe and Gross enrolment ratio (%) in Papua New Guinea?
Provide a short and direct response. 32.6. In the year 1990, what is the difference between the Gross enrolment ratio (%) of Central Europe and Gross enrolment ratio (%) of Russian Federation?
Give a very brief answer. -12.5. In the year 1990, what is the difference between the Gross enrolment ratio (%) in Burundi and Gross enrolment ratio (%) in Papua New Guinea?
Make the answer very short. 5.41. In the year 1990, what is the difference between the Gross enrolment ratio (%) of Burundi and Gross enrolment ratio (%) of Russian Federation?
Offer a very short reply. -39.69. In the year 1990, what is the difference between the Gross enrolment ratio (%) in Papua New Guinea and Gross enrolment ratio (%) in Russian Federation?
Offer a terse response. -45.11. What is the ratio of the Gross enrolment ratio (%) of Central Europe in 1982 to that in 1984?
Provide a succinct answer. 0.99. What is the ratio of the Gross enrolment ratio (%) in Burundi in 1982 to that in 1984?
Ensure brevity in your answer.  0.72. What is the ratio of the Gross enrolment ratio (%) in Papua New Guinea in 1982 to that in 1984?
Offer a very short reply. 0.95. What is the ratio of the Gross enrolment ratio (%) of Burundi in 1982 to that in 1986?
Offer a terse response. 0.61. What is the ratio of the Gross enrolment ratio (%) of Papua New Guinea in 1982 to that in 1986?
Offer a terse response. 0.9. What is the ratio of the Gross enrolment ratio (%) of Russian Federation in 1982 to that in 1986?
Give a very brief answer. 0.98. What is the ratio of the Gross enrolment ratio (%) in Central Europe in 1982 to that in 1987?
Provide a succinct answer. 1.01. What is the ratio of the Gross enrolment ratio (%) in Burundi in 1982 to that in 1987?
Give a very brief answer. 0.55. What is the ratio of the Gross enrolment ratio (%) in Papua New Guinea in 1982 to that in 1987?
Your response must be concise. 0.89. What is the ratio of the Gross enrolment ratio (%) of Russian Federation in 1982 to that in 1987?
Offer a very short reply. 0.95. What is the ratio of the Gross enrolment ratio (%) in Central Europe in 1982 to that in 1988?
Offer a very short reply. 1.02. What is the ratio of the Gross enrolment ratio (%) in Burundi in 1982 to that in 1988?
Give a very brief answer. 0.5. What is the ratio of the Gross enrolment ratio (%) in Papua New Guinea in 1982 to that in 1988?
Keep it short and to the point. 0.87. What is the ratio of the Gross enrolment ratio (%) of Burundi in 1982 to that in 1989?
Ensure brevity in your answer.  0.49. What is the ratio of the Gross enrolment ratio (%) of Papua New Guinea in 1982 to that in 1989?
Your answer should be compact. 0.84. What is the ratio of the Gross enrolment ratio (%) in Russian Federation in 1982 to that in 1989?
Provide a succinct answer. 0.95. What is the ratio of the Gross enrolment ratio (%) in Central Europe in 1982 to that in 1990?
Provide a short and direct response. 1.05. What is the ratio of the Gross enrolment ratio (%) in Burundi in 1982 to that in 1990?
Offer a terse response. 0.49. What is the ratio of the Gross enrolment ratio (%) of Papua New Guinea in 1982 to that in 1990?
Offer a very short reply. 0.86. What is the ratio of the Gross enrolment ratio (%) of Russian Federation in 1982 to that in 1990?
Provide a succinct answer. 0.95. What is the ratio of the Gross enrolment ratio (%) of Central Europe in 1984 to that in 1986?
Provide a succinct answer. 1.01. What is the ratio of the Gross enrolment ratio (%) in Burundi in 1984 to that in 1986?
Your answer should be compact. 0.85. What is the ratio of the Gross enrolment ratio (%) in Papua New Guinea in 1984 to that in 1986?
Ensure brevity in your answer.  0.96. What is the ratio of the Gross enrolment ratio (%) in Russian Federation in 1984 to that in 1986?
Your answer should be very brief. 0.97. What is the ratio of the Gross enrolment ratio (%) of Central Europe in 1984 to that in 1987?
Your answer should be compact. 1.02. What is the ratio of the Gross enrolment ratio (%) of Burundi in 1984 to that in 1987?
Make the answer very short. 0.76. What is the ratio of the Gross enrolment ratio (%) in Papua New Guinea in 1984 to that in 1987?
Give a very brief answer. 0.94. What is the ratio of the Gross enrolment ratio (%) in Russian Federation in 1984 to that in 1987?
Ensure brevity in your answer.  0.95. What is the ratio of the Gross enrolment ratio (%) of Central Europe in 1984 to that in 1988?
Offer a terse response. 1.04. What is the ratio of the Gross enrolment ratio (%) of Burundi in 1984 to that in 1988?
Your answer should be compact. 0.68. What is the ratio of the Gross enrolment ratio (%) of Papua New Guinea in 1984 to that in 1988?
Your answer should be compact. 0.92. What is the ratio of the Gross enrolment ratio (%) in Russian Federation in 1984 to that in 1988?
Your answer should be very brief. 0.94. What is the ratio of the Gross enrolment ratio (%) of Central Europe in 1984 to that in 1989?
Your response must be concise. 1.05. What is the ratio of the Gross enrolment ratio (%) in Burundi in 1984 to that in 1989?
Offer a very short reply. 0.67. What is the ratio of the Gross enrolment ratio (%) of Papua New Guinea in 1984 to that in 1989?
Your response must be concise. 0.89. What is the ratio of the Gross enrolment ratio (%) in Russian Federation in 1984 to that in 1989?
Make the answer very short. 0.94. What is the ratio of the Gross enrolment ratio (%) of Central Europe in 1984 to that in 1990?
Provide a short and direct response. 1.06. What is the ratio of the Gross enrolment ratio (%) of Burundi in 1984 to that in 1990?
Provide a succinct answer. 0.67. What is the ratio of the Gross enrolment ratio (%) in Papua New Guinea in 1984 to that in 1990?
Offer a very short reply. 0.91. What is the ratio of the Gross enrolment ratio (%) in Russian Federation in 1984 to that in 1990?
Your answer should be very brief. 0.94. What is the ratio of the Gross enrolment ratio (%) of Central Europe in 1986 to that in 1987?
Your response must be concise. 1.01. What is the ratio of the Gross enrolment ratio (%) of Burundi in 1986 to that in 1987?
Provide a short and direct response. 0.9. What is the ratio of the Gross enrolment ratio (%) of Papua New Guinea in 1986 to that in 1987?
Offer a very short reply. 0.98. What is the ratio of the Gross enrolment ratio (%) in Russian Federation in 1986 to that in 1987?
Provide a succinct answer. 0.97. What is the ratio of the Gross enrolment ratio (%) in Central Europe in 1986 to that in 1988?
Your answer should be compact. 1.03. What is the ratio of the Gross enrolment ratio (%) in Burundi in 1986 to that in 1988?
Your answer should be very brief. 0.81. What is the ratio of the Gross enrolment ratio (%) of Papua New Guinea in 1986 to that in 1988?
Give a very brief answer. 0.96. What is the ratio of the Gross enrolment ratio (%) in Russian Federation in 1986 to that in 1988?
Keep it short and to the point. 0.97. What is the ratio of the Gross enrolment ratio (%) of Central Europe in 1986 to that in 1989?
Your answer should be very brief. 1.04. What is the ratio of the Gross enrolment ratio (%) of Burundi in 1986 to that in 1989?
Provide a short and direct response. 0.8. What is the ratio of the Gross enrolment ratio (%) in Papua New Guinea in 1986 to that in 1989?
Provide a succinct answer. 0.93. What is the ratio of the Gross enrolment ratio (%) of Russian Federation in 1986 to that in 1989?
Provide a succinct answer. 0.97. What is the ratio of the Gross enrolment ratio (%) in Central Europe in 1986 to that in 1990?
Offer a terse response. 1.05. What is the ratio of the Gross enrolment ratio (%) in Burundi in 1986 to that in 1990?
Your answer should be compact. 0.79. What is the ratio of the Gross enrolment ratio (%) in Papua New Guinea in 1986 to that in 1990?
Your response must be concise. 0.95. What is the ratio of the Gross enrolment ratio (%) of Russian Federation in 1986 to that in 1990?
Provide a succinct answer. 0.97. What is the ratio of the Gross enrolment ratio (%) in Central Europe in 1987 to that in 1988?
Your answer should be compact. 1.02. What is the ratio of the Gross enrolment ratio (%) of Burundi in 1987 to that in 1988?
Offer a terse response. 0.9. What is the ratio of the Gross enrolment ratio (%) of Papua New Guinea in 1987 to that in 1988?
Offer a very short reply. 0.98. What is the ratio of the Gross enrolment ratio (%) in Russian Federation in 1987 to that in 1988?
Provide a short and direct response. 0.99. What is the ratio of the Gross enrolment ratio (%) in Central Europe in 1987 to that in 1989?
Provide a short and direct response. 1.03. What is the ratio of the Gross enrolment ratio (%) in Burundi in 1987 to that in 1989?
Keep it short and to the point. 0.88. What is the ratio of the Gross enrolment ratio (%) in Papua New Guinea in 1987 to that in 1989?
Offer a very short reply. 0.95. What is the ratio of the Gross enrolment ratio (%) of Central Europe in 1987 to that in 1990?
Ensure brevity in your answer.  1.04. What is the ratio of the Gross enrolment ratio (%) in Burundi in 1987 to that in 1990?
Ensure brevity in your answer.  0.88. What is the ratio of the Gross enrolment ratio (%) of Papua New Guinea in 1987 to that in 1990?
Make the answer very short. 0.97. What is the ratio of the Gross enrolment ratio (%) of Central Europe in 1988 to that in 1989?
Ensure brevity in your answer.  1.01. What is the ratio of the Gross enrolment ratio (%) in Burundi in 1988 to that in 1989?
Keep it short and to the point. 0.99. What is the ratio of the Gross enrolment ratio (%) in Papua New Guinea in 1988 to that in 1989?
Your answer should be very brief. 0.97. What is the ratio of the Gross enrolment ratio (%) in Central Europe in 1988 to that in 1990?
Ensure brevity in your answer.  1.03. What is the ratio of the Gross enrolment ratio (%) in Burundi in 1988 to that in 1990?
Provide a succinct answer. 0.99. What is the ratio of the Gross enrolment ratio (%) in Papua New Guinea in 1988 to that in 1990?
Give a very brief answer. 0.99. What is the ratio of the Gross enrolment ratio (%) of Central Europe in 1989 to that in 1990?
Offer a very short reply. 1.01. What is the ratio of the Gross enrolment ratio (%) in Papua New Guinea in 1989 to that in 1990?
Make the answer very short. 1.02. What is the difference between the highest and the second highest Gross enrolment ratio (%) in Central Europe?
Your answer should be compact. 0.97. What is the difference between the highest and the second highest Gross enrolment ratio (%) of Burundi?
Your answer should be very brief. 0.1. What is the difference between the highest and the second highest Gross enrolment ratio (%) of Papua New Guinea?
Keep it short and to the point. 1.37. What is the difference between the highest and the second highest Gross enrolment ratio (%) of Russian Federation?
Keep it short and to the point. 0.33. What is the difference between the highest and the lowest Gross enrolment ratio (%) of Central Europe?
Give a very brief answer. 6.01. What is the difference between the highest and the lowest Gross enrolment ratio (%) in Burundi?
Provide a short and direct response. 34.46. What is the difference between the highest and the lowest Gross enrolment ratio (%) in Papua New Guinea?
Give a very brief answer. 10.26. What is the difference between the highest and the lowest Gross enrolment ratio (%) in Russian Federation?
Offer a very short reply. 6.41. 